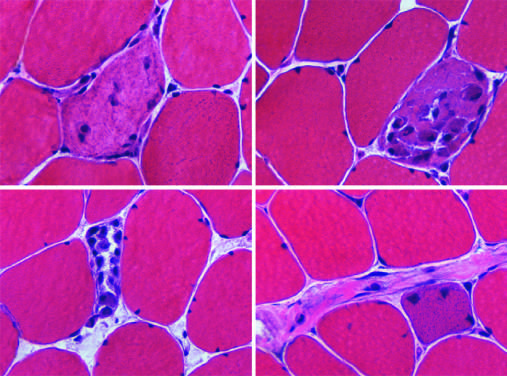what are necrotic cells infiltrated by?
Answer the question using a single word or phrase. Variable numbers of inflammatory cells 